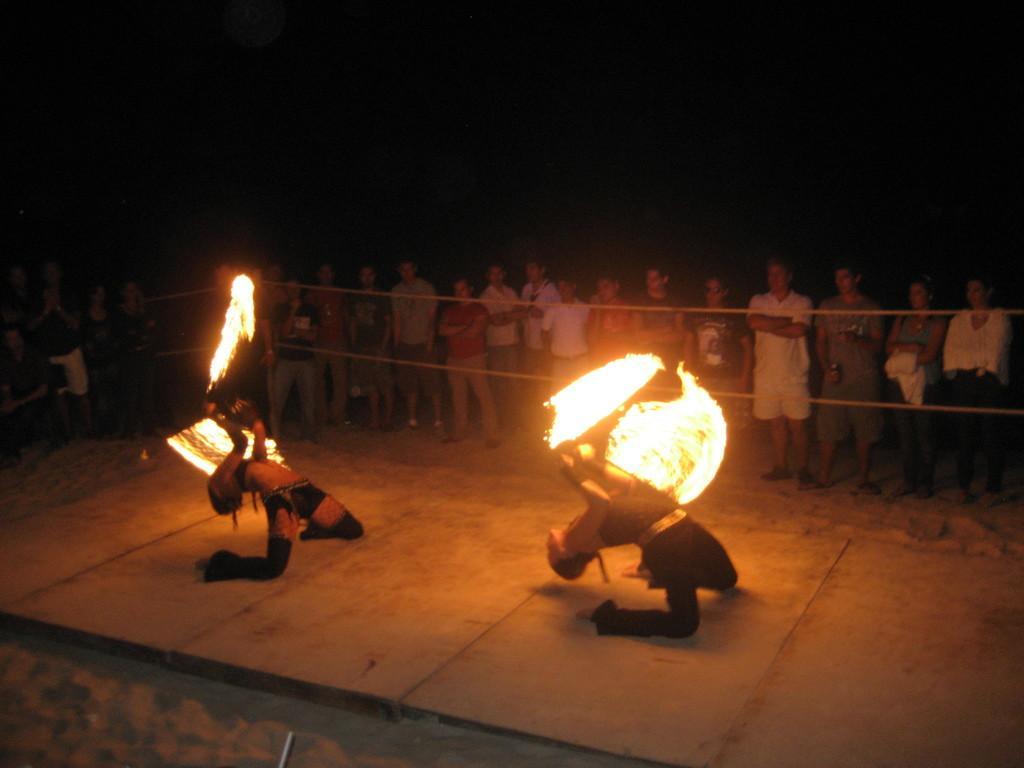In one or two sentences, can you explain what this image depicts? In this picture there are people those who are standing in front of a boundary in the center of the image and there are two people those who are performing the stunt in the center of the image. with fire. 